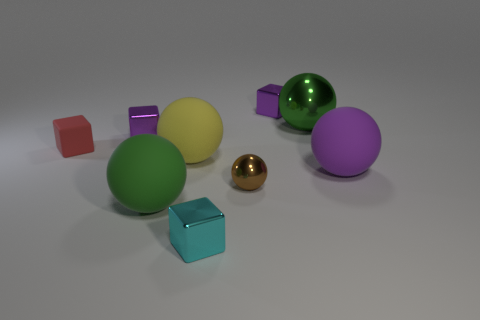Subtract all green metal spheres. How many spheres are left? 4 Add 1 tiny blue metallic blocks. How many objects exist? 10 Subtract all brown balls. How many balls are left? 4 Subtract 2 spheres. How many spheres are left? 3 Subtract all blocks. How many objects are left? 5 Subtract all brown blocks. Subtract all gray balls. How many blocks are left? 4 Subtract all purple cylinders. How many cyan blocks are left? 1 Add 1 tiny shiny things. How many tiny shiny things exist? 5 Subtract 1 green balls. How many objects are left? 8 Subtract all purple shiny cylinders. Subtract all small spheres. How many objects are left? 8 